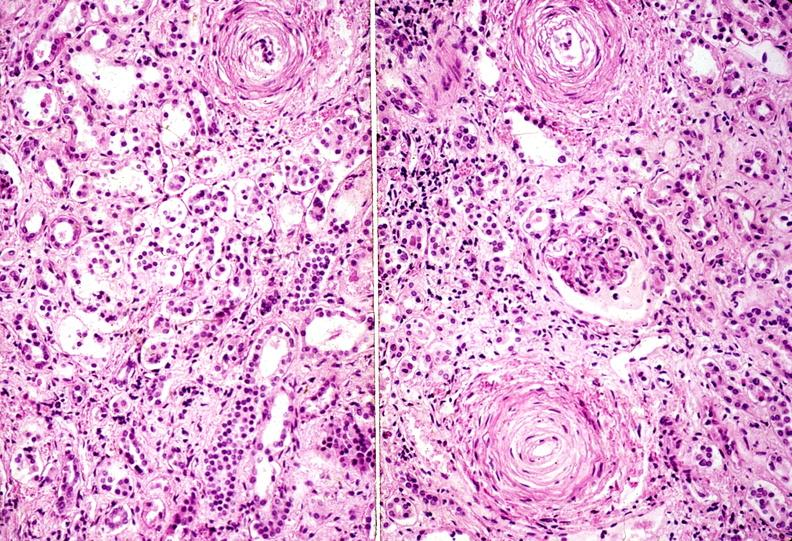what does this image show?
Answer the question using a single word or phrase. Kidney 